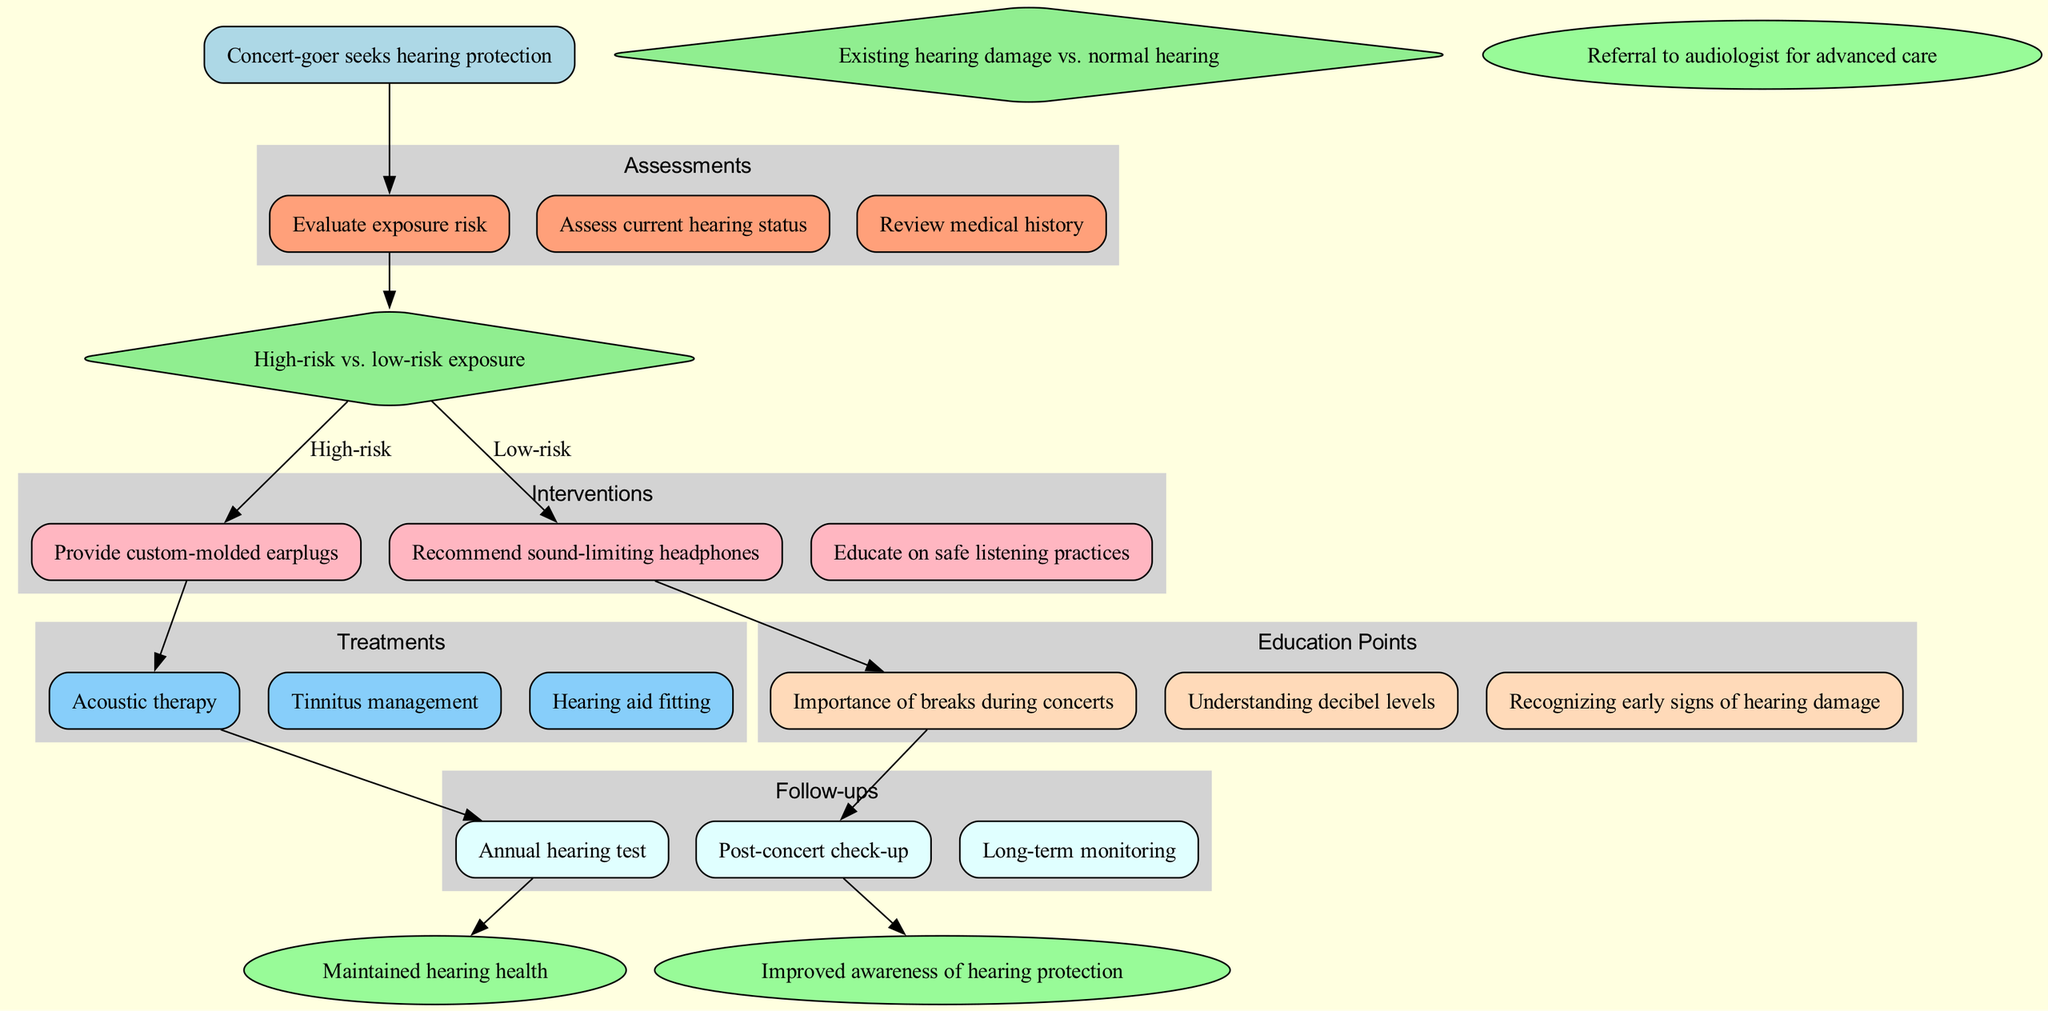What is the starting point of the clinical pathway? The starting point is clearly indicated in the diagram as "Concert-goer seeks hearing protection". This can be found at the top node before any assessments take place.
Answer: Concert-goer seeks hearing protection How many assessments are listed in the diagram? By counting the nodes in the "Assessments" cluster, we can see there are three specific assessments mentioned: "Evaluate exposure risk," "Assess current hearing status," and "Review medical history."
Answer: 3 What decision follows a high-risk exposure assessment? The diagram connects a high-risk exposure assessment to the intervention node "Provide custom-molded earplugs." Therefore, the decision made regarding high-risk exposure directly leads to that specific intervention.
Answer: Provide custom-molded earplugs What is the last step in the clinical pathway for a concert-goer? Following all the interventions, treatments, follow-ups, and education points, the final outcomes listed are "Maintained hearing health," "Improved awareness of hearing protection," and "Referral to audiologist for advanced care." To answer which is the last, we see "Referral to audiologist for advanced care" is the last endpoint shown in the diagram.
Answer: Referral to audiologist for advanced care Which intervention is linked to education? When assessing the flow from the low-risk exposure decision, the intervention leads to the education point "Educate on safe listening practices." This establishes a clear link between the intervention and education aspect.
Answer: Educate on safe listening practices How many follow-up steps are included in the pathway? The "Follow-ups" section consists of three distinct follow-up steps: "Annual hearing test," "Post-concert check-up," and "Long-term monitoring." This can be verified by counting the nodes under the follow-ups cluster in the diagram.
Answer: 3 What treatment is associated with tinnitus management? Among the three treatments, "Tinnitus management" is directly stated as one of the treatments in the "Treatments" cluster, showing its relevance to the concert-goer’s needs.
Answer: Tinnitus management What is a key education point for concert-goers? One of the critical education points listed is "Understanding decibel levels," highlighting an essential aspect for concert-goers to be aware of to protect their hearing. This is emphasized in the "Education Points" section of the diagram.
Answer: Understanding decibel levels 